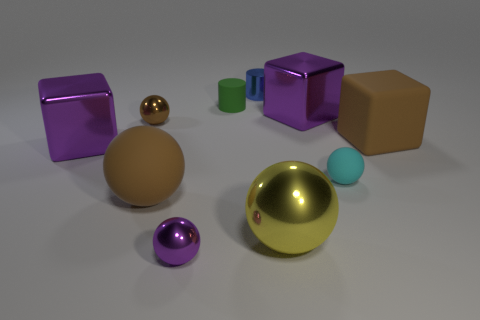How many other objects are there of the same color as the large rubber cube?
Give a very brief answer. 2. There is a brown rubber thing behind the tiny cyan rubber sphere; what number of big brown rubber balls are to the right of it?
Make the answer very short. 0. There is a green matte cylinder; are there any small cyan balls to the right of it?
Offer a terse response. Yes. The big metallic thing in front of the sphere to the right of the yellow metal sphere is what shape?
Keep it short and to the point. Sphere. Is the number of green matte things that are on the right side of the purple metal sphere less than the number of tiny shiny things that are in front of the brown metallic sphere?
Provide a short and direct response. No. There is another large matte object that is the same shape as the cyan matte thing; what color is it?
Offer a very short reply. Brown. How many small matte objects are both behind the big matte cube and to the right of the large shiny ball?
Give a very brief answer. 0. Is the number of tiny metal balls behind the rubber cylinder greater than the number of rubber cubes that are behind the tiny metal cylinder?
Ensure brevity in your answer.  No. The cyan rubber sphere is what size?
Offer a very short reply. Small. Is there a big metallic object that has the same shape as the small purple metal object?
Ensure brevity in your answer.  Yes. 